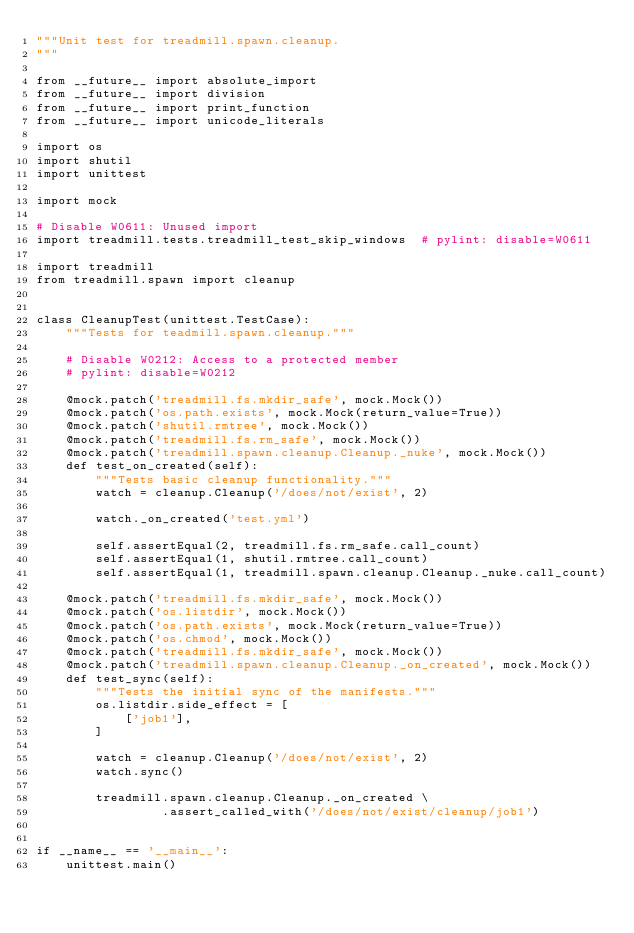<code> <loc_0><loc_0><loc_500><loc_500><_Python_>"""Unit test for treadmill.spawn.cleanup.
"""

from __future__ import absolute_import
from __future__ import division
from __future__ import print_function
from __future__ import unicode_literals

import os
import shutil
import unittest

import mock

# Disable W0611: Unused import
import treadmill.tests.treadmill_test_skip_windows  # pylint: disable=W0611

import treadmill
from treadmill.spawn import cleanup


class CleanupTest(unittest.TestCase):
    """Tests for teadmill.spawn.cleanup."""

    # Disable W0212: Access to a protected member
    # pylint: disable=W0212

    @mock.patch('treadmill.fs.mkdir_safe', mock.Mock())
    @mock.patch('os.path.exists', mock.Mock(return_value=True))
    @mock.patch('shutil.rmtree', mock.Mock())
    @mock.patch('treadmill.fs.rm_safe', mock.Mock())
    @mock.patch('treadmill.spawn.cleanup.Cleanup._nuke', mock.Mock())
    def test_on_created(self):
        """Tests basic cleanup functionality."""
        watch = cleanup.Cleanup('/does/not/exist', 2)

        watch._on_created('test.yml')

        self.assertEqual(2, treadmill.fs.rm_safe.call_count)
        self.assertEqual(1, shutil.rmtree.call_count)
        self.assertEqual(1, treadmill.spawn.cleanup.Cleanup._nuke.call_count)

    @mock.patch('treadmill.fs.mkdir_safe', mock.Mock())
    @mock.patch('os.listdir', mock.Mock())
    @mock.patch('os.path.exists', mock.Mock(return_value=True))
    @mock.patch('os.chmod', mock.Mock())
    @mock.patch('treadmill.fs.mkdir_safe', mock.Mock())
    @mock.patch('treadmill.spawn.cleanup.Cleanup._on_created', mock.Mock())
    def test_sync(self):
        """Tests the initial sync of the manifests."""
        os.listdir.side_effect = [
            ['job1'],
        ]

        watch = cleanup.Cleanup('/does/not/exist', 2)
        watch.sync()

        treadmill.spawn.cleanup.Cleanup._on_created \
                 .assert_called_with('/does/not/exist/cleanup/job1')


if __name__ == '__main__':
    unittest.main()
</code> 